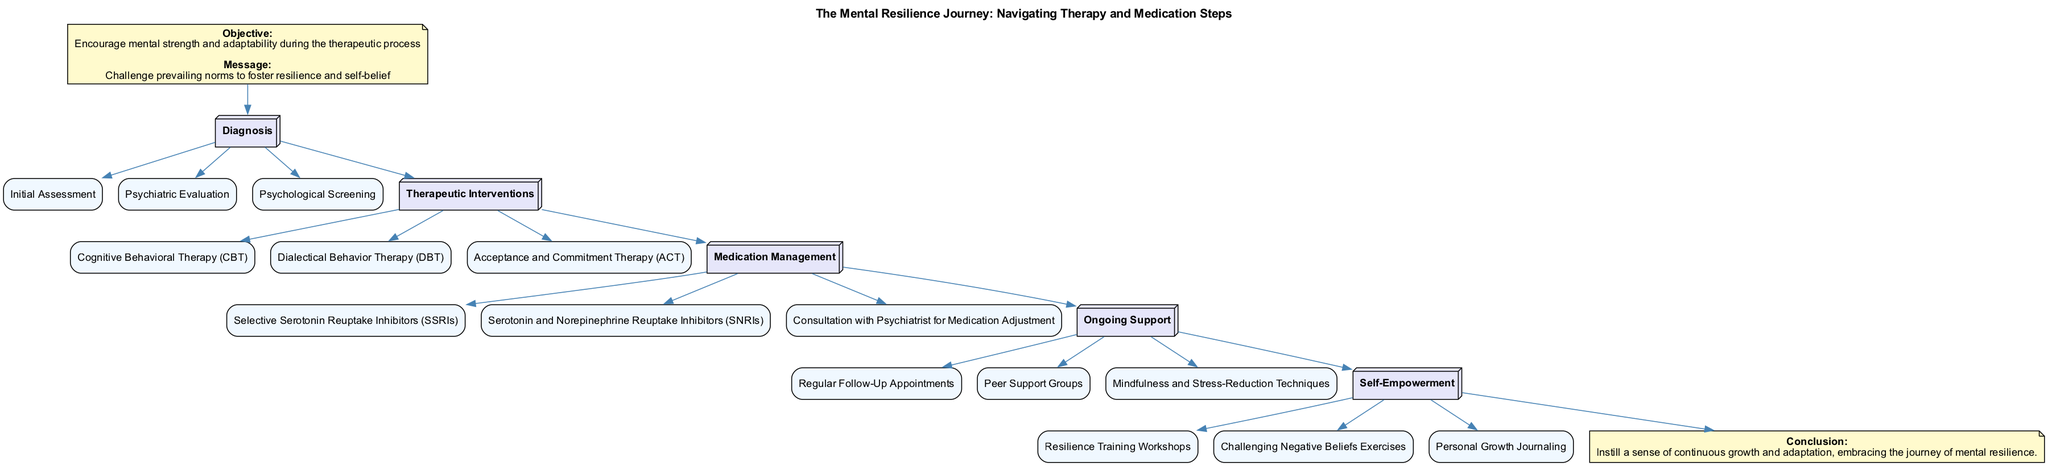What are the three elements in the Diagnosis phase? The Diagnosis phase contains three elements: Initial Assessment, Psychiatric Evaluation, Psychological Screening. This is directly listed under the Diagnosis phase in the diagram.
Answer: Initial Assessment, Psychiatric Evaluation, Psychological Screening How many phases are there in the clinical pathway? The diagram shows a total of five phases: Diagnosis, Therapeutic Interventions, Medication Management, Ongoing Support, and Self-Empowerment. By counting these phases, one can confirm the total.
Answer: 5 What is the first element of the Therapeutic Interventions phase? The first element in the Therapeutic Interventions phase is Cognitive Behavioral Therapy (CBT). This can be found by looking at the elements listed under that phase in the diagram.
Answer: Cognitive Behavioral Therapy (CBT) Which phase comes after Medication Management? The phase that comes after Medication Management in the diagram is Ongoing Support. By tracing the connections from one phase to the next, the subsequent phase can be identified.
Answer: Ongoing Support What type of therapy is included in the Therapeutic Interventions phase that focuses on acceptance? The type of therapy included in the Therapeutic Interventions phase that focuses on acceptance is Acceptance and Commitment Therapy (ACT). This is specifically mentioned as one of the elements in that phase.
Answer: Acceptance and Commitment Therapy (ACT) How do the elements in the Ongoing Support phase contribute to the journey? The elements in the Ongoing Support phase include Regular Follow-Up Appointments, Peer Support Groups, and Mindfulness and Stress-Reduction Techniques, which contribute to continuous support during the recovery journey. These elements provide ongoing assistance and resources throughout the mental resilience process.
Answer: Regular Follow-Up Appointments, Peer Support Groups, Mindfulness and Stress-Reduction Techniques What is the purpose of the Self-Empowerment phase? The purpose of the Self-Empowerment phase is to engage individuals in activities such as Resilience Training Workshops, Challenging Negative Beliefs Exercises, and Personal Growth Journaling, fostering an increased sense of strength and belief in personal capabilities. This can be understood from the description of the elements in that phase.
Answer: Resilience Training Workshops, Challenging Negative Beliefs Exercises, Personal Growth Journaling How are the phases connected in terms of the journey of mental resilience? The phases are connected sequentially, with each phase leading into the next, showing a clear progression through Diagnosis, Therapeutic Interventions, Medication Management, Ongoing Support, and then culminating in Self-Empowerment. This flow illustrates the structured path one takes in the mental resilience journey.
Answer: Sequentially 